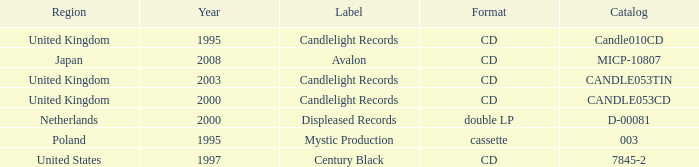What was the Candlelight Records Catalog of Candle053tin format? CD. 